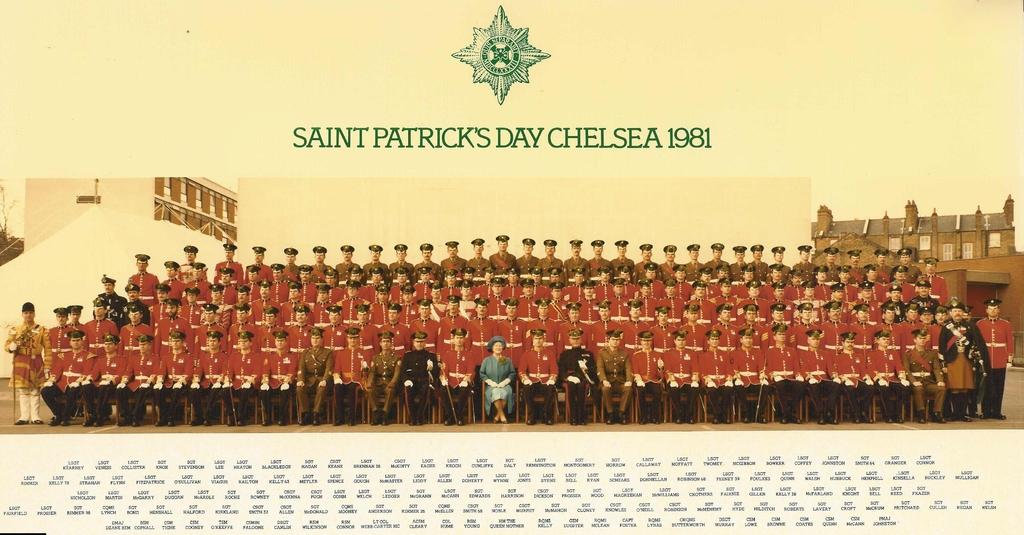<image>
Render a clear and concise summary of the photo. Picture showing soldiers and the words "Saint Patricks Day" on top. 